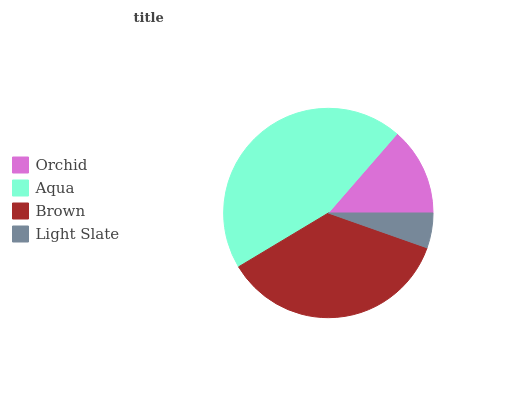Is Light Slate the minimum?
Answer yes or no. Yes. Is Aqua the maximum?
Answer yes or no. Yes. Is Brown the minimum?
Answer yes or no. No. Is Brown the maximum?
Answer yes or no. No. Is Aqua greater than Brown?
Answer yes or no. Yes. Is Brown less than Aqua?
Answer yes or no. Yes. Is Brown greater than Aqua?
Answer yes or no. No. Is Aqua less than Brown?
Answer yes or no. No. Is Brown the high median?
Answer yes or no. Yes. Is Orchid the low median?
Answer yes or no. Yes. Is Aqua the high median?
Answer yes or no. No. Is Brown the low median?
Answer yes or no. No. 